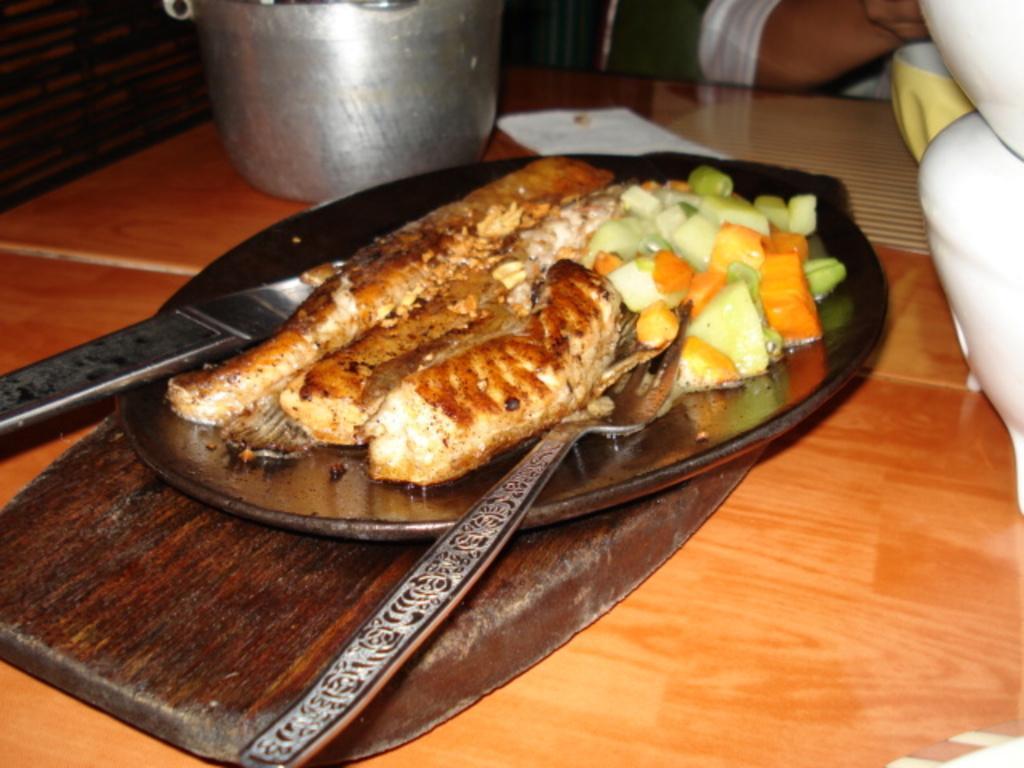Can you describe this image briefly? In this image there is a plate with food served in it and kept on a table, beside that there is person. 